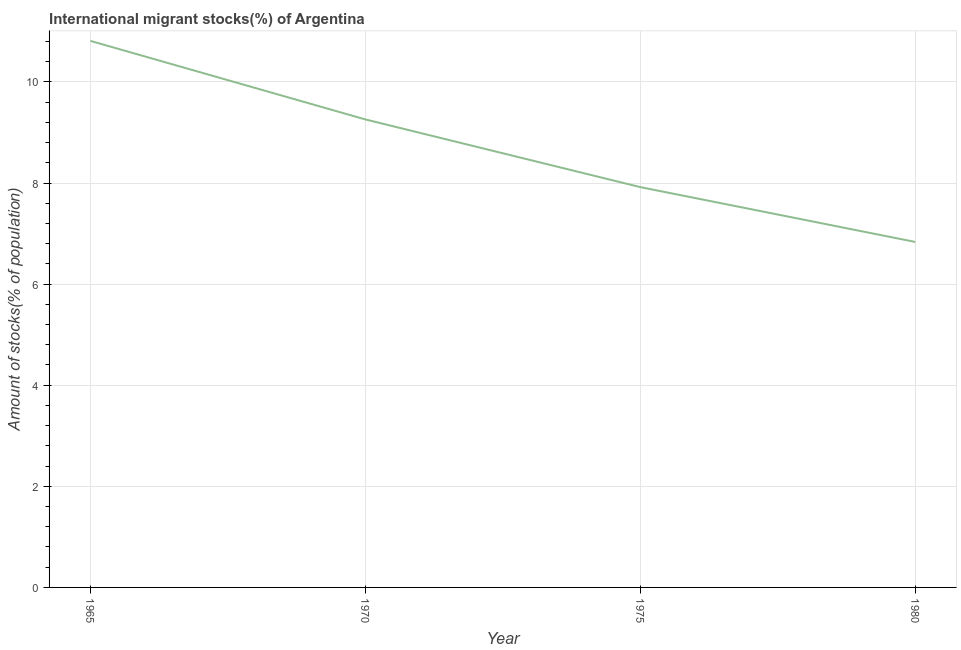What is the number of international migrant stocks in 1965?
Your answer should be compact. 10.81. Across all years, what is the maximum number of international migrant stocks?
Make the answer very short. 10.81. Across all years, what is the minimum number of international migrant stocks?
Offer a very short reply. 6.83. In which year was the number of international migrant stocks maximum?
Offer a very short reply. 1965. In which year was the number of international migrant stocks minimum?
Ensure brevity in your answer.  1980. What is the sum of the number of international migrant stocks?
Your response must be concise. 34.82. What is the difference between the number of international migrant stocks in 1965 and 1975?
Your answer should be compact. 2.89. What is the average number of international migrant stocks per year?
Your answer should be compact. 8.71. What is the median number of international migrant stocks?
Ensure brevity in your answer.  8.59. What is the ratio of the number of international migrant stocks in 1975 to that in 1980?
Ensure brevity in your answer.  1.16. Is the difference between the number of international migrant stocks in 1970 and 1980 greater than the difference between any two years?
Your response must be concise. No. What is the difference between the highest and the second highest number of international migrant stocks?
Offer a very short reply. 1.55. Is the sum of the number of international migrant stocks in 1965 and 1975 greater than the maximum number of international migrant stocks across all years?
Offer a very short reply. Yes. What is the difference between the highest and the lowest number of international migrant stocks?
Your answer should be compact. 3.98. In how many years, is the number of international migrant stocks greater than the average number of international migrant stocks taken over all years?
Provide a short and direct response. 2. Does the number of international migrant stocks monotonically increase over the years?
Provide a short and direct response. No. How many lines are there?
Give a very brief answer. 1. How many years are there in the graph?
Offer a terse response. 4. What is the title of the graph?
Ensure brevity in your answer.  International migrant stocks(%) of Argentina. What is the label or title of the X-axis?
Ensure brevity in your answer.  Year. What is the label or title of the Y-axis?
Provide a short and direct response. Amount of stocks(% of population). What is the Amount of stocks(% of population) of 1965?
Make the answer very short. 10.81. What is the Amount of stocks(% of population) in 1970?
Your answer should be compact. 9.26. What is the Amount of stocks(% of population) of 1975?
Your answer should be compact. 7.92. What is the Amount of stocks(% of population) of 1980?
Ensure brevity in your answer.  6.83. What is the difference between the Amount of stocks(% of population) in 1965 and 1970?
Keep it short and to the point. 1.55. What is the difference between the Amount of stocks(% of population) in 1965 and 1975?
Ensure brevity in your answer.  2.89. What is the difference between the Amount of stocks(% of population) in 1965 and 1980?
Your answer should be very brief. 3.98. What is the difference between the Amount of stocks(% of population) in 1970 and 1975?
Give a very brief answer. 1.34. What is the difference between the Amount of stocks(% of population) in 1970 and 1980?
Make the answer very short. 2.42. What is the difference between the Amount of stocks(% of population) in 1975 and 1980?
Give a very brief answer. 1.08. What is the ratio of the Amount of stocks(% of population) in 1965 to that in 1970?
Your response must be concise. 1.17. What is the ratio of the Amount of stocks(% of population) in 1965 to that in 1975?
Your answer should be very brief. 1.36. What is the ratio of the Amount of stocks(% of population) in 1965 to that in 1980?
Your response must be concise. 1.58. What is the ratio of the Amount of stocks(% of population) in 1970 to that in 1975?
Offer a terse response. 1.17. What is the ratio of the Amount of stocks(% of population) in 1970 to that in 1980?
Provide a short and direct response. 1.35. What is the ratio of the Amount of stocks(% of population) in 1975 to that in 1980?
Your answer should be very brief. 1.16. 